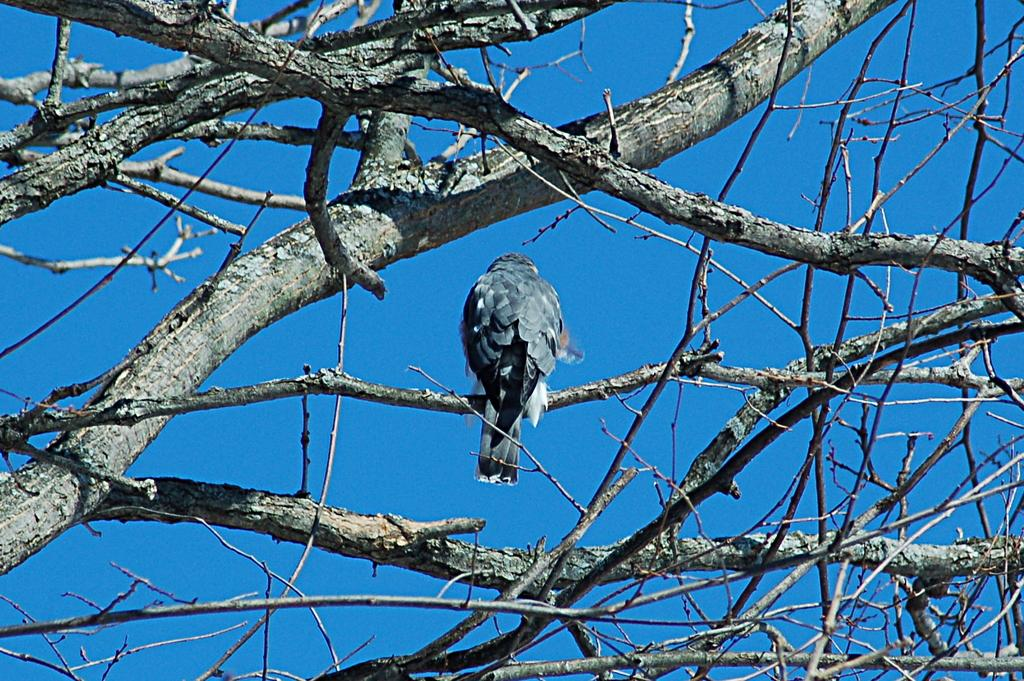What type of animal can be seen in the image? There is a bird in the image. Where is the bird located in the image? The bird is sitting on a branch of a tree. What is visible in the background of the image? There is a sky visible in the image. What type of pen is the bird holding in the image? There is no pen present in the image; the bird is sitting on a branch of a tree. 